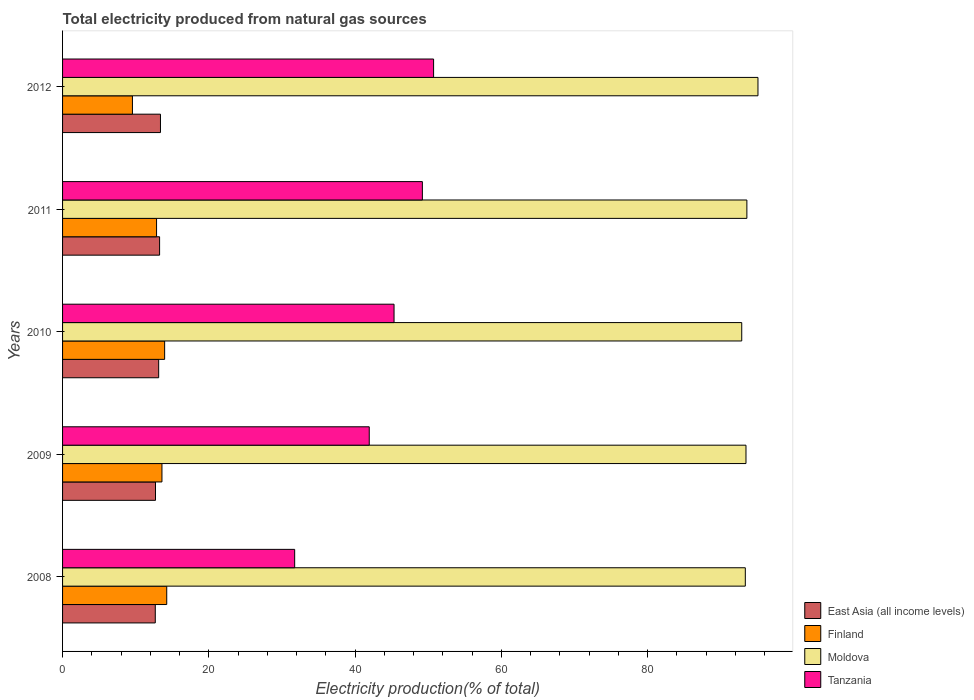How many different coloured bars are there?
Your answer should be very brief. 4. How many groups of bars are there?
Provide a succinct answer. 5. Are the number of bars per tick equal to the number of legend labels?
Offer a very short reply. Yes. How many bars are there on the 3rd tick from the bottom?
Keep it short and to the point. 4. What is the total electricity produced in Finland in 2011?
Your answer should be very brief. 12.85. Across all years, what is the maximum total electricity produced in Moldova?
Give a very brief answer. 95.09. Across all years, what is the minimum total electricity produced in Moldova?
Provide a succinct answer. 92.87. What is the total total electricity produced in East Asia (all income levels) in the graph?
Your answer should be very brief. 65.18. What is the difference between the total electricity produced in Tanzania in 2008 and that in 2009?
Offer a terse response. -10.2. What is the difference between the total electricity produced in Tanzania in 2009 and the total electricity produced in Finland in 2008?
Provide a short and direct response. 27.69. What is the average total electricity produced in East Asia (all income levels) per year?
Make the answer very short. 13.04. In the year 2010, what is the difference between the total electricity produced in East Asia (all income levels) and total electricity produced in Finland?
Ensure brevity in your answer.  -0.82. What is the ratio of the total electricity produced in East Asia (all income levels) in 2009 to that in 2011?
Keep it short and to the point. 0.96. Is the difference between the total electricity produced in East Asia (all income levels) in 2008 and 2012 greater than the difference between the total electricity produced in Finland in 2008 and 2012?
Give a very brief answer. No. What is the difference between the highest and the second highest total electricity produced in Moldova?
Offer a terse response. 1.52. What is the difference between the highest and the lowest total electricity produced in Finland?
Keep it short and to the point. 4.69. What does the 1st bar from the top in 2011 represents?
Provide a succinct answer. Tanzania. What does the 1st bar from the bottom in 2011 represents?
Your response must be concise. East Asia (all income levels). Are the values on the major ticks of X-axis written in scientific E-notation?
Your answer should be very brief. No. What is the title of the graph?
Make the answer very short. Total electricity produced from natural gas sources. What is the Electricity production(% of total) in East Asia (all income levels) in 2008?
Your response must be concise. 12.68. What is the Electricity production(% of total) of Finland in 2008?
Your answer should be compact. 14.24. What is the Electricity production(% of total) of Moldova in 2008?
Give a very brief answer. 93.36. What is the Electricity production(% of total) in Tanzania in 2008?
Offer a very short reply. 31.74. What is the Electricity production(% of total) in East Asia (all income levels) in 2009?
Offer a very short reply. 12.71. What is the Electricity production(% of total) of Finland in 2009?
Make the answer very short. 13.59. What is the Electricity production(% of total) of Moldova in 2009?
Keep it short and to the point. 93.45. What is the Electricity production(% of total) of Tanzania in 2009?
Offer a very short reply. 41.93. What is the Electricity production(% of total) of East Asia (all income levels) in 2010?
Your answer should be compact. 13.14. What is the Electricity production(% of total) in Finland in 2010?
Keep it short and to the point. 13.96. What is the Electricity production(% of total) of Moldova in 2010?
Offer a very short reply. 92.87. What is the Electricity production(% of total) of Tanzania in 2010?
Keep it short and to the point. 45.32. What is the Electricity production(% of total) of East Asia (all income levels) in 2011?
Your response must be concise. 13.27. What is the Electricity production(% of total) in Finland in 2011?
Your answer should be compact. 12.85. What is the Electricity production(% of total) in Moldova in 2011?
Ensure brevity in your answer.  93.57. What is the Electricity production(% of total) of Tanzania in 2011?
Keep it short and to the point. 49.2. What is the Electricity production(% of total) of East Asia (all income levels) in 2012?
Ensure brevity in your answer.  13.39. What is the Electricity production(% of total) of Finland in 2012?
Your response must be concise. 9.55. What is the Electricity production(% of total) of Moldova in 2012?
Keep it short and to the point. 95.09. What is the Electricity production(% of total) in Tanzania in 2012?
Make the answer very short. 50.73. Across all years, what is the maximum Electricity production(% of total) in East Asia (all income levels)?
Your response must be concise. 13.39. Across all years, what is the maximum Electricity production(% of total) of Finland?
Your answer should be compact. 14.24. Across all years, what is the maximum Electricity production(% of total) of Moldova?
Your answer should be very brief. 95.09. Across all years, what is the maximum Electricity production(% of total) of Tanzania?
Your response must be concise. 50.73. Across all years, what is the minimum Electricity production(% of total) of East Asia (all income levels)?
Provide a short and direct response. 12.68. Across all years, what is the minimum Electricity production(% of total) of Finland?
Your response must be concise. 9.55. Across all years, what is the minimum Electricity production(% of total) in Moldova?
Make the answer very short. 92.87. Across all years, what is the minimum Electricity production(% of total) in Tanzania?
Your answer should be compact. 31.74. What is the total Electricity production(% of total) of East Asia (all income levels) in the graph?
Your answer should be very brief. 65.18. What is the total Electricity production(% of total) in Finland in the graph?
Keep it short and to the point. 64.2. What is the total Electricity production(% of total) of Moldova in the graph?
Your response must be concise. 468.33. What is the total Electricity production(% of total) of Tanzania in the graph?
Ensure brevity in your answer.  218.93. What is the difference between the Electricity production(% of total) in East Asia (all income levels) in 2008 and that in 2009?
Keep it short and to the point. -0.03. What is the difference between the Electricity production(% of total) of Finland in 2008 and that in 2009?
Make the answer very short. 0.65. What is the difference between the Electricity production(% of total) in Moldova in 2008 and that in 2009?
Offer a very short reply. -0.09. What is the difference between the Electricity production(% of total) of Tanzania in 2008 and that in 2009?
Offer a very short reply. -10.2. What is the difference between the Electricity production(% of total) in East Asia (all income levels) in 2008 and that in 2010?
Offer a very short reply. -0.46. What is the difference between the Electricity production(% of total) in Finland in 2008 and that in 2010?
Offer a very short reply. 0.29. What is the difference between the Electricity production(% of total) of Moldova in 2008 and that in 2010?
Provide a short and direct response. 0.49. What is the difference between the Electricity production(% of total) in Tanzania in 2008 and that in 2010?
Give a very brief answer. -13.59. What is the difference between the Electricity production(% of total) of East Asia (all income levels) in 2008 and that in 2011?
Your answer should be compact. -0.59. What is the difference between the Electricity production(% of total) in Finland in 2008 and that in 2011?
Keep it short and to the point. 1.39. What is the difference between the Electricity production(% of total) of Moldova in 2008 and that in 2011?
Your answer should be compact. -0.21. What is the difference between the Electricity production(% of total) of Tanzania in 2008 and that in 2011?
Your response must be concise. -17.46. What is the difference between the Electricity production(% of total) in East Asia (all income levels) in 2008 and that in 2012?
Provide a short and direct response. -0.71. What is the difference between the Electricity production(% of total) in Finland in 2008 and that in 2012?
Your response must be concise. 4.69. What is the difference between the Electricity production(% of total) in Moldova in 2008 and that in 2012?
Your answer should be compact. -1.73. What is the difference between the Electricity production(% of total) of Tanzania in 2008 and that in 2012?
Make the answer very short. -19. What is the difference between the Electricity production(% of total) of East Asia (all income levels) in 2009 and that in 2010?
Your response must be concise. -0.43. What is the difference between the Electricity production(% of total) in Finland in 2009 and that in 2010?
Ensure brevity in your answer.  -0.37. What is the difference between the Electricity production(% of total) in Moldova in 2009 and that in 2010?
Offer a terse response. 0.58. What is the difference between the Electricity production(% of total) in Tanzania in 2009 and that in 2010?
Your answer should be compact. -3.39. What is the difference between the Electricity production(% of total) in East Asia (all income levels) in 2009 and that in 2011?
Provide a succinct answer. -0.56. What is the difference between the Electricity production(% of total) of Finland in 2009 and that in 2011?
Your response must be concise. 0.74. What is the difference between the Electricity production(% of total) in Moldova in 2009 and that in 2011?
Provide a short and direct response. -0.12. What is the difference between the Electricity production(% of total) in Tanzania in 2009 and that in 2011?
Your response must be concise. -7.26. What is the difference between the Electricity production(% of total) in East Asia (all income levels) in 2009 and that in 2012?
Keep it short and to the point. -0.68. What is the difference between the Electricity production(% of total) in Finland in 2009 and that in 2012?
Give a very brief answer. 4.04. What is the difference between the Electricity production(% of total) of Moldova in 2009 and that in 2012?
Offer a very short reply. -1.64. What is the difference between the Electricity production(% of total) of Tanzania in 2009 and that in 2012?
Keep it short and to the point. -8.8. What is the difference between the Electricity production(% of total) of East Asia (all income levels) in 2010 and that in 2011?
Make the answer very short. -0.13. What is the difference between the Electricity production(% of total) in Finland in 2010 and that in 2011?
Make the answer very short. 1.1. What is the difference between the Electricity production(% of total) in Moldova in 2010 and that in 2011?
Provide a succinct answer. -0.7. What is the difference between the Electricity production(% of total) in Tanzania in 2010 and that in 2011?
Give a very brief answer. -3.87. What is the difference between the Electricity production(% of total) of East Asia (all income levels) in 2010 and that in 2012?
Ensure brevity in your answer.  -0.25. What is the difference between the Electricity production(% of total) of Finland in 2010 and that in 2012?
Make the answer very short. 4.4. What is the difference between the Electricity production(% of total) in Moldova in 2010 and that in 2012?
Offer a very short reply. -2.22. What is the difference between the Electricity production(% of total) in Tanzania in 2010 and that in 2012?
Provide a short and direct response. -5.41. What is the difference between the Electricity production(% of total) of East Asia (all income levels) in 2011 and that in 2012?
Your answer should be compact. -0.12. What is the difference between the Electricity production(% of total) in Finland in 2011 and that in 2012?
Your answer should be very brief. 3.3. What is the difference between the Electricity production(% of total) of Moldova in 2011 and that in 2012?
Your answer should be very brief. -1.52. What is the difference between the Electricity production(% of total) in Tanzania in 2011 and that in 2012?
Keep it short and to the point. -1.53. What is the difference between the Electricity production(% of total) in East Asia (all income levels) in 2008 and the Electricity production(% of total) in Finland in 2009?
Make the answer very short. -0.91. What is the difference between the Electricity production(% of total) in East Asia (all income levels) in 2008 and the Electricity production(% of total) in Moldova in 2009?
Provide a succinct answer. -80.77. What is the difference between the Electricity production(% of total) in East Asia (all income levels) in 2008 and the Electricity production(% of total) in Tanzania in 2009?
Your response must be concise. -29.26. What is the difference between the Electricity production(% of total) of Finland in 2008 and the Electricity production(% of total) of Moldova in 2009?
Make the answer very short. -79.21. What is the difference between the Electricity production(% of total) of Finland in 2008 and the Electricity production(% of total) of Tanzania in 2009?
Provide a succinct answer. -27.69. What is the difference between the Electricity production(% of total) of Moldova in 2008 and the Electricity production(% of total) of Tanzania in 2009?
Your answer should be very brief. 51.42. What is the difference between the Electricity production(% of total) of East Asia (all income levels) in 2008 and the Electricity production(% of total) of Finland in 2010?
Give a very brief answer. -1.28. What is the difference between the Electricity production(% of total) of East Asia (all income levels) in 2008 and the Electricity production(% of total) of Moldova in 2010?
Your answer should be compact. -80.19. What is the difference between the Electricity production(% of total) in East Asia (all income levels) in 2008 and the Electricity production(% of total) in Tanzania in 2010?
Make the answer very short. -32.65. What is the difference between the Electricity production(% of total) of Finland in 2008 and the Electricity production(% of total) of Moldova in 2010?
Ensure brevity in your answer.  -78.62. What is the difference between the Electricity production(% of total) of Finland in 2008 and the Electricity production(% of total) of Tanzania in 2010?
Make the answer very short. -31.08. What is the difference between the Electricity production(% of total) of Moldova in 2008 and the Electricity production(% of total) of Tanzania in 2010?
Provide a succinct answer. 48.03. What is the difference between the Electricity production(% of total) in East Asia (all income levels) in 2008 and the Electricity production(% of total) in Finland in 2011?
Your response must be concise. -0.17. What is the difference between the Electricity production(% of total) in East Asia (all income levels) in 2008 and the Electricity production(% of total) in Moldova in 2011?
Ensure brevity in your answer.  -80.89. What is the difference between the Electricity production(% of total) in East Asia (all income levels) in 2008 and the Electricity production(% of total) in Tanzania in 2011?
Offer a very short reply. -36.52. What is the difference between the Electricity production(% of total) of Finland in 2008 and the Electricity production(% of total) of Moldova in 2011?
Provide a succinct answer. -79.33. What is the difference between the Electricity production(% of total) of Finland in 2008 and the Electricity production(% of total) of Tanzania in 2011?
Offer a terse response. -34.96. What is the difference between the Electricity production(% of total) of Moldova in 2008 and the Electricity production(% of total) of Tanzania in 2011?
Your response must be concise. 44.16. What is the difference between the Electricity production(% of total) in East Asia (all income levels) in 2008 and the Electricity production(% of total) in Finland in 2012?
Your answer should be compact. 3.12. What is the difference between the Electricity production(% of total) in East Asia (all income levels) in 2008 and the Electricity production(% of total) in Moldova in 2012?
Offer a terse response. -82.41. What is the difference between the Electricity production(% of total) of East Asia (all income levels) in 2008 and the Electricity production(% of total) of Tanzania in 2012?
Offer a terse response. -38.06. What is the difference between the Electricity production(% of total) in Finland in 2008 and the Electricity production(% of total) in Moldova in 2012?
Ensure brevity in your answer.  -80.84. What is the difference between the Electricity production(% of total) of Finland in 2008 and the Electricity production(% of total) of Tanzania in 2012?
Offer a very short reply. -36.49. What is the difference between the Electricity production(% of total) of Moldova in 2008 and the Electricity production(% of total) of Tanzania in 2012?
Your response must be concise. 42.62. What is the difference between the Electricity production(% of total) of East Asia (all income levels) in 2009 and the Electricity production(% of total) of Finland in 2010?
Provide a succinct answer. -1.25. What is the difference between the Electricity production(% of total) of East Asia (all income levels) in 2009 and the Electricity production(% of total) of Moldova in 2010?
Make the answer very short. -80.16. What is the difference between the Electricity production(% of total) in East Asia (all income levels) in 2009 and the Electricity production(% of total) in Tanzania in 2010?
Your answer should be very brief. -32.62. What is the difference between the Electricity production(% of total) of Finland in 2009 and the Electricity production(% of total) of Moldova in 2010?
Make the answer very short. -79.28. What is the difference between the Electricity production(% of total) in Finland in 2009 and the Electricity production(% of total) in Tanzania in 2010?
Your response must be concise. -31.74. What is the difference between the Electricity production(% of total) of Moldova in 2009 and the Electricity production(% of total) of Tanzania in 2010?
Your response must be concise. 48.12. What is the difference between the Electricity production(% of total) in East Asia (all income levels) in 2009 and the Electricity production(% of total) in Finland in 2011?
Your answer should be compact. -0.14. What is the difference between the Electricity production(% of total) in East Asia (all income levels) in 2009 and the Electricity production(% of total) in Moldova in 2011?
Ensure brevity in your answer.  -80.86. What is the difference between the Electricity production(% of total) of East Asia (all income levels) in 2009 and the Electricity production(% of total) of Tanzania in 2011?
Ensure brevity in your answer.  -36.49. What is the difference between the Electricity production(% of total) in Finland in 2009 and the Electricity production(% of total) in Moldova in 2011?
Offer a terse response. -79.98. What is the difference between the Electricity production(% of total) of Finland in 2009 and the Electricity production(% of total) of Tanzania in 2011?
Provide a short and direct response. -35.61. What is the difference between the Electricity production(% of total) in Moldova in 2009 and the Electricity production(% of total) in Tanzania in 2011?
Offer a very short reply. 44.25. What is the difference between the Electricity production(% of total) of East Asia (all income levels) in 2009 and the Electricity production(% of total) of Finland in 2012?
Keep it short and to the point. 3.15. What is the difference between the Electricity production(% of total) of East Asia (all income levels) in 2009 and the Electricity production(% of total) of Moldova in 2012?
Your response must be concise. -82.38. What is the difference between the Electricity production(% of total) in East Asia (all income levels) in 2009 and the Electricity production(% of total) in Tanzania in 2012?
Make the answer very short. -38.03. What is the difference between the Electricity production(% of total) of Finland in 2009 and the Electricity production(% of total) of Moldova in 2012?
Ensure brevity in your answer.  -81.5. What is the difference between the Electricity production(% of total) in Finland in 2009 and the Electricity production(% of total) in Tanzania in 2012?
Give a very brief answer. -37.14. What is the difference between the Electricity production(% of total) in Moldova in 2009 and the Electricity production(% of total) in Tanzania in 2012?
Offer a terse response. 42.72. What is the difference between the Electricity production(% of total) of East Asia (all income levels) in 2010 and the Electricity production(% of total) of Finland in 2011?
Make the answer very short. 0.29. What is the difference between the Electricity production(% of total) of East Asia (all income levels) in 2010 and the Electricity production(% of total) of Moldova in 2011?
Offer a very short reply. -80.43. What is the difference between the Electricity production(% of total) in East Asia (all income levels) in 2010 and the Electricity production(% of total) in Tanzania in 2011?
Make the answer very short. -36.06. What is the difference between the Electricity production(% of total) of Finland in 2010 and the Electricity production(% of total) of Moldova in 2011?
Your response must be concise. -79.61. What is the difference between the Electricity production(% of total) of Finland in 2010 and the Electricity production(% of total) of Tanzania in 2011?
Your answer should be compact. -35.24. What is the difference between the Electricity production(% of total) in Moldova in 2010 and the Electricity production(% of total) in Tanzania in 2011?
Keep it short and to the point. 43.67. What is the difference between the Electricity production(% of total) in East Asia (all income levels) in 2010 and the Electricity production(% of total) in Finland in 2012?
Your answer should be very brief. 3.59. What is the difference between the Electricity production(% of total) in East Asia (all income levels) in 2010 and the Electricity production(% of total) in Moldova in 2012?
Offer a very short reply. -81.95. What is the difference between the Electricity production(% of total) of East Asia (all income levels) in 2010 and the Electricity production(% of total) of Tanzania in 2012?
Provide a succinct answer. -37.59. What is the difference between the Electricity production(% of total) of Finland in 2010 and the Electricity production(% of total) of Moldova in 2012?
Give a very brief answer. -81.13. What is the difference between the Electricity production(% of total) of Finland in 2010 and the Electricity production(% of total) of Tanzania in 2012?
Your answer should be compact. -36.78. What is the difference between the Electricity production(% of total) in Moldova in 2010 and the Electricity production(% of total) in Tanzania in 2012?
Offer a very short reply. 42.13. What is the difference between the Electricity production(% of total) of East Asia (all income levels) in 2011 and the Electricity production(% of total) of Finland in 2012?
Your answer should be very brief. 3.71. What is the difference between the Electricity production(% of total) of East Asia (all income levels) in 2011 and the Electricity production(% of total) of Moldova in 2012?
Your response must be concise. -81.82. What is the difference between the Electricity production(% of total) in East Asia (all income levels) in 2011 and the Electricity production(% of total) in Tanzania in 2012?
Provide a short and direct response. -37.47. What is the difference between the Electricity production(% of total) of Finland in 2011 and the Electricity production(% of total) of Moldova in 2012?
Give a very brief answer. -82.24. What is the difference between the Electricity production(% of total) in Finland in 2011 and the Electricity production(% of total) in Tanzania in 2012?
Provide a short and direct response. -37.88. What is the difference between the Electricity production(% of total) of Moldova in 2011 and the Electricity production(% of total) of Tanzania in 2012?
Provide a short and direct response. 42.84. What is the average Electricity production(% of total) of East Asia (all income levels) per year?
Make the answer very short. 13.04. What is the average Electricity production(% of total) in Finland per year?
Your response must be concise. 12.84. What is the average Electricity production(% of total) of Moldova per year?
Offer a terse response. 93.67. What is the average Electricity production(% of total) in Tanzania per year?
Offer a very short reply. 43.79. In the year 2008, what is the difference between the Electricity production(% of total) of East Asia (all income levels) and Electricity production(% of total) of Finland?
Offer a very short reply. -1.57. In the year 2008, what is the difference between the Electricity production(% of total) of East Asia (all income levels) and Electricity production(% of total) of Moldova?
Provide a short and direct response. -80.68. In the year 2008, what is the difference between the Electricity production(% of total) in East Asia (all income levels) and Electricity production(% of total) in Tanzania?
Offer a very short reply. -19.06. In the year 2008, what is the difference between the Electricity production(% of total) of Finland and Electricity production(% of total) of Moldova?
Keep it short and to the point. -79.11. In the year 2008, what is the difference between the Electricity production(% of total) in Finland and Electricity production(% of total) in Tanzania?
Offer a very short reply. -17.49. In the year 2008, what is the difference between the Electricity production(% of total) in Moldova and Electricity production(% of total) in Tanzania?
Ensure brevity in your answer.  61.62. In the year 2009, what is the difference between the Electricity production(% of total) of East Asia (all income levels) and Electricity production(% of total) of Finland?
Provide a succinct answer. -0.88. In the year 2009, what is the difference between the Electricity production(% of total) in East Asia (all income levels) and Electricity production(% of total) in Moldova?
Provide a short and direct response. -80.74. In the year 2009, what is the difference between the Electricity production(% of total) of East Asia (all income levels) and Electricity production(% of total) of Tanzania?
Your answer should be compact. -29.23. In the year 2009, what is the difference between the Electricity production(% of total) of Finland and Electricity production(% of total) of Moldova?
Give a very brief answer. -79.86. In the year 2009, what is the difference between the Electricity production(% of total) of Finland and Electricity production(% of total) of Tanzania?
Your answer should be very brief. -28.34. In the year 2009, what is the difference between the Electricity production(% of total) of Moldova and Electricity production(% of total) of Tanzania?
Offer a terse response. 51.52. In the year 2010, what is the difference between the Electricity production(% of total) of East Asia (all income levels) and Electricity production(% of total) of Finland?
Your answer should be very brief. -0.82. In the year 2010, what is the difference between the Electricity production(% of total) of East Asia (all income levels) and Electricity production(% of total) of Moldova?
Your answer should be compact. -79.73. In the year 2010, what is the difference between the Electricity production(% of total) in East Asia (all income levels) and Electricity production(% of total) in Tanzania?
Your answer should be very brief. -32.18. In the year 2010, what is the difference between the Electricity production(% of total) of Finland and Electricity production(% of total) of Moldova?
Provide a short and direct response. -78.91. In the year 2010, what is the difference between the Electricity production(% of total) in Finland and Electricity production(% of total) in Tanzania?
Ensure brevity in your answer.  -31.37. In the year 2010, what is the difference between the Electricity production(% of total) in Moldova and Electricity production(% of total) in Tanzania?
Give a very brief answer. 47.54. In the year 2011, what is the difference between the Electricity production(% of total) in East Asia (all income levels) and Electricity production(% of total) in Finland?
Offer a very short reply. 0.42. In the year 2011, what is the difference between the Electricity production(% of total) of East Asia (all income levels) and Electricity production(% of total) of Moldova?
Offer a very short reply. -80.3. In the year 2011, what is the difference between the Electricity production(% of total) of East Asia (all income levels) and Electricity production(% of total) of Tanzania?
Offer a very short reply. -35.93. In the year 2011, what is the difference between the Electricity production(% of total) of Finland and Electricity production(% of total) of Moldova?
Your answer should be compact. -80.72. In the year 2011, what is the difference between the Electricity production(% of total) in Finland and Electricity production(% of total) in Tanzania?
Your response must be concise. -36.35. In the year 2011, what is the difference between the Electricity production(% of total) of Moldova and Electricity production(% of total) of Tanzania?
Your response must be concise. 44.37. In the year 2012, what is the difference between the Electricity production(% of total) of East Asia (all income levels) and Electricity production(% of total) of Finland?
Offer a very short reply. 3.83. In the year 2012, what is the difference between the Electricity production(% of total) in East Asia (all income levels) and Electricity production(% of total) in Moldova?
Ensure brevity in your answer.  -81.7. In the year 2012, what is the difference between the Electricity production(% of total) of East Asia (all income levels) and Electricity production(% of total) of Tanzania?
Your response must be concise. -37.35. In the year 2012, what is the difference between the Electricity production(% of total) in Finland and Electricity production(% of total) in Moldova?
Offer a terse response. -85.53. In the year 2012, what is the difference between the Electricity production(% of total) in Finland and Electricity production(% of total) in Tanzania?
Provide a short and direct response. -41.18. In the year 2012, what is the difference between the Electricity production(% of total) of Moldova and Electricity production(% of total) of Tanzania?
Provide a succinct answer. 44.35. What is the ratio of the Electricity production(% of total) in Finland in 2008 to that in 2009?
Your response must be concise. 1.05. What is the ratio of the Electricity production(% of total) of Moldova in 2008 to that in 2009?
Give a very brief answer. 1. What is the ratio of the Electricity production(% of total) of Tanzania in 2008 to that in 2009?
Make the answer very short. 0.76. What is the ratio of the Electricity production(% of total) of East Asia (all income levels) in 2008 to that in 2010?
Make the answer very short. 0.96. What is the ratio of the Electricity production(% of total) in Finland in 2008 to that in 2010?
Your answer should be compact. 1.02. What is the ratio of the Electricity production(% of total) in Moldova in 2008 to that in 2010?
Keep it short and to the point. 1.01. What is the ratio of the Electricity production(% of total) of Tanzania in 2008 to that in 2010?
Offer a very short reply. 0.7. What is the ratio of the Electricity production(% of total) in East Asia (all income levels) in 2008 to that in 2011?
Offer a terse response. 0.96. What is the ratio of the Electricity production(% of total) of Finland in 2008 to that in 2011?
Provide a short and direct response. 1.11. What is the ratio of the Electricity production(% of total) in Tanzania in 2008 to that in 2011?
Your response must be concise. 0.65. What is the ratio of the Electricity production(% of total) of East Asia (all income levels) in 2008 to that in 2012?
Provide a short and direct response. 0.95. What is the ratio of the Electricity production(% of total) in Finland in 2008 to that in 2012?
Ensure brevity in your answer.  1.49. What is the ratio of the Electricity production(% of total) of Moldova in 2008 to that in 2012?
Keep it short and to the point. 0.98. What is the ratio of the Electricity production(% of total) in Tanzania in 2008 to that in 2012?
Provide a short and direct response. 0.63. What is the ratio of the Electricity production(% of total) in East Asia (all income levels) in 2009 to that in 2010?
Your answer should be very brief. 0.97. What is the ratio of the Electricity production(% of total) in Finland in 2009 to that in 2010?
Your answer should be compact. 0.97. What is the ratio of the Electricity production(% of total) in Moldova in 2009 to that in 2010?
Ensure brevity in your answer.  1.01. What is the ratio of the Electricity production(% of total) in Tanzania in 2009 to that in 2010?
Provide a short and direct response. 0.93. What is the ratio of the Electricity production(% of total) of East Asia (all income levels) in 2009 to that in 2011?
Offer a terse response. 0.96. What is the ratio of the Electricity production(% of total) in Finland in 2009 to that in 2011?
Ensure brevity in your answer.  1.06. What is the ratio of the Electricity production(% of total) in Moldova in 2009 to that in 2011?
Offer a very short reply. 1. What is the ratio of the Electricity production(% of total) of Tanzania in 2009 to that in 2011?
Provide a short and direct response. 0.85. What is the ratio of the Electricity production(% of total) of East Asia (all income levels) in 2009 to that in 2012?
Your answer should be very brief. 0.95. What is the ratio of the Electricity production(% of total) of Finland in 2009 to that in 2012?
Your answer should be compact. 1.42. What is the ratio of the Electricity production(% of total) of Moldova in 2009 to that in 2012?
Your answer should be compact. 0.98. What is the ratio of the Electricity production(% of total) in Tanzania in 2009 to that in 2012?
Offer a very short reply. 0.83. What is the ratio of the Electricity production(% of total) in Finland in 2010 to that in 2011?
Make the answer very short. 1.09. What is the ratio of the Electricity production(% of total) of Tanzania in 2010 to that in 2011?
Your answer should be compact. 0.92. What is the ratio of the Electricity production(% of total) of East Asia (all income levels) in 2010 to that in 2012?
Give a very brief answer. 0.98. What is the ratio of the Electricity production(% of total) in Finland in 2010 to that in 2012?
Give a very brief answer. 1.46. What is the ratio of the Electricity production(% of total) in Moldova in 2010 to that in 2012?
Give a very brief answer. 0.98. What is the ratio of the Electricity production(% of total) of Tanzania in 2010 to that in 2012?
Your response must be concise. 0.89. What is the ratio of the Electricity production(% of total) in Finland in 2011 to that in 2012?
Your answer should be compact. 1.35. What is the ratio of the Electricity production(% of total) of Moldova in 2011 to that in 2012?
Provide a succinct answer. 0.98. What is the ratio of the Electricity production(% of total) in Tanzania in 2011 to that in 2012?
Keep it short and to the point. 0.97. What is the difference between the highest and the second highest Electricity production(% of total) in East Asia (all income levels)?
Your answer should be compact. 0.12. What is the difference between the highest and the second highest Electricity production(% of total) in Finland?
Your response must be concise. 0.29. What is the difference between the highest and the second highest Electricity production(% of total) in Moldova?
Your answer should be very brief. 1.52. What is the difference between the highest and the second highest Electricity production(% of total) of Tanzania?
Give a very brief answer. 1.53. What is the difference between the highest and the lowest Electricity production(% of total) in East Asia (all income levels)?
Offer a very short reply. 0.71. What is the difference between the highest and the lowest Electricity production(% of total) in Finland?
Keep it short and to the point. 4.69. What is the difference between the highest and the lowest Electricity production(% of total) of Moldova?
Offer a terse response. 2.22. What is the difference between the highest and the lowest Electricity production(% of total) of Tanzania?
Provide a succinct answer. 19. 